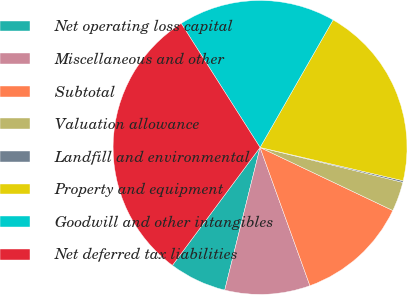Convert chart to OTSL. <chart><loc_0><loc_0><loc_500><loc_500><pie_chart><fcel>Net operating loss capital<fcel>Miscellaneous and other<fcel>Subtotal<fcel>Valuation allowance<fcel>Landfill and environmental<fcel>Property and equipment<fcel>Goodwill and other intangibles<fcel>Net deferred tax liabilities<nl><fcel>6.31%<fcel>9.37%<fcel>12.43%<fcel>3.24%<fcel>0.18%<fcel>20.36%<fcel>17.29%<fcel>30.81%<nl></chart> 